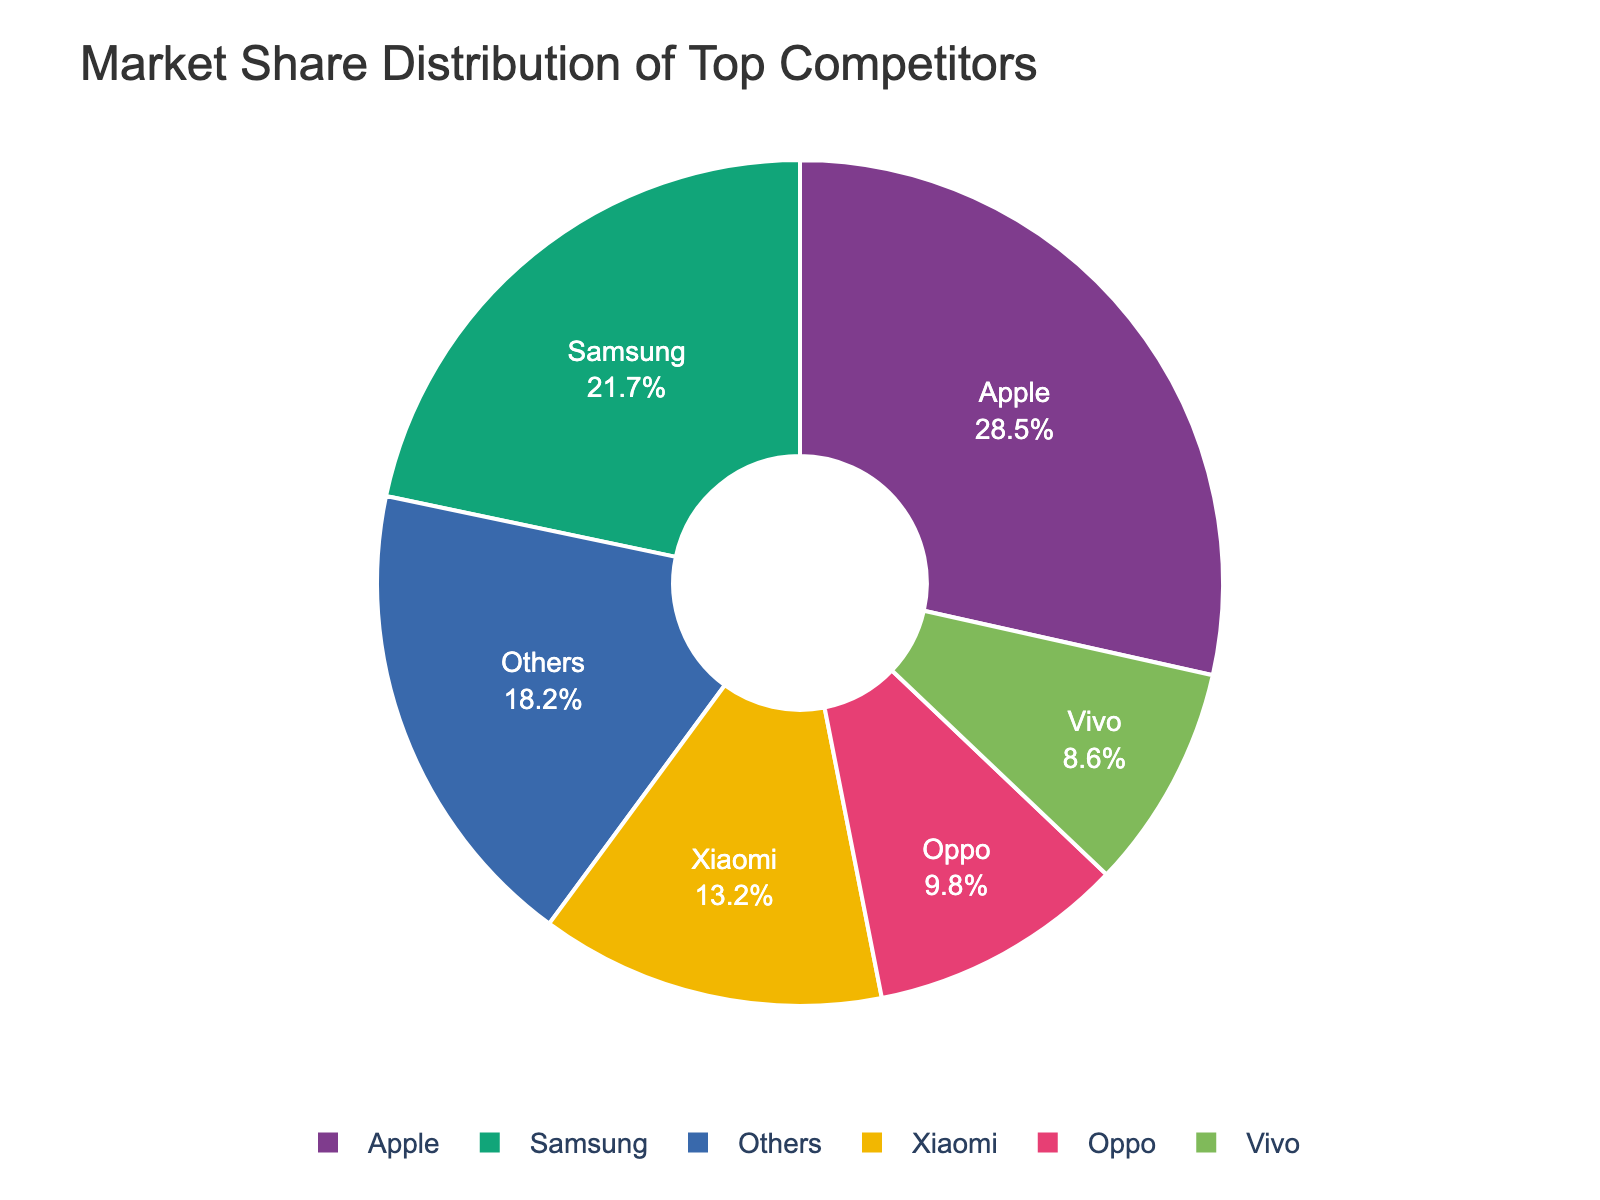What is the market share of the company with the smallest slice in the pie chart? The smallest slice corresponds to Vivo. According to the data, Vivo has a market share of 8.6%.
Answer: 8.6% Which company has the largest market share and how much is it? The largest slice in the pie chart corresponds to Apple. According to the data, Apple has the highest market share of 28.5%.
Answer: Apple, 28.5% Compare the combined market share of Xiaomi and Oppo with that of Samsung. Which is greater and by how much? First, add Xiaomi’s market share (13.2%) to Oppo’s market share (9.8%) which gives a combined market share of 23%. Samsung's market share is 21.7%. Subtract Samsung's market share from the combined market share of Xiaomi and Oppo (23% - 21.7% = 1.3%). Thus, the combined market share of Xiaomi and Oppo is greater by 1.3%.
Answer: Combined Xiaomi and Oppo by 1.3% What is the color of Apple's slice in the pie chart? Since the pie chart is colored using a specific qualitative color sequence, the color of Apple's slice is based on the first color in the sequence usually allocated. In the Bold color sequence of Plotly, Apple's slice is often colored red.
Answer: Red Which two companies together hold a market share closest to 30%? Comparing paired sums, Xiaomi and Oppo have a combined market share of 23%. Checking others, Vivo and Others total to 26.8%, while Samsung and Oppo total to 31.5%. Therefore, Vivo and Others combined at 26.8% is the closest to 30%.
Answer: Vivo and Others Which company has more market share, Oppo or Vivo, and by how much? Oppo has a market share of 9.8% while Vivo has a market share of 8.6%. Subtract Vivo's market share from Oppo's (9.8% - 8.6% = 1.2%). Oppo has a market share greater by 1.2%.
Answer: Oppo by 1.2% What is the sum of the market shares of companies excluding the "Others" category? Add the market shares of Apple (28.5%), Samsung (21.7%), Xiaomi (13.2%), Oppo (9.8%), and Vivo (8.6%). The sum is 28.5 + 21.7 + 13.2 + 9.8 + 8.6 = 81.8%.
Answer: 81.8% Calculate the average market share of Samsung, Xiaomi, and Oppo. Add the market shares of Samsung (21.7%), Xiaomi (13.2%), and Oppo (9.8%) together: 21.7 + 13.2 + 9.8 = 44.7. Then divide by the number of companies (3) to get the average: 44.7 / 3 = 14.9%.
Answer: 14.9% How much more market share does Apple have compared to all companies except "Others"? The total market share of all companies except "Others" is 81.8%. Apple's market share is 28.5%. To find the difference, 81.8% - 28.5% = 53.3%.
Answer: 53.3% Identify the company with the third-largest market share and give their percentage. The third-largest slice in the pie chart corresponds to Xiaomi with a market share of 13.2%.
Answer: Xiaomi, 13.2% 